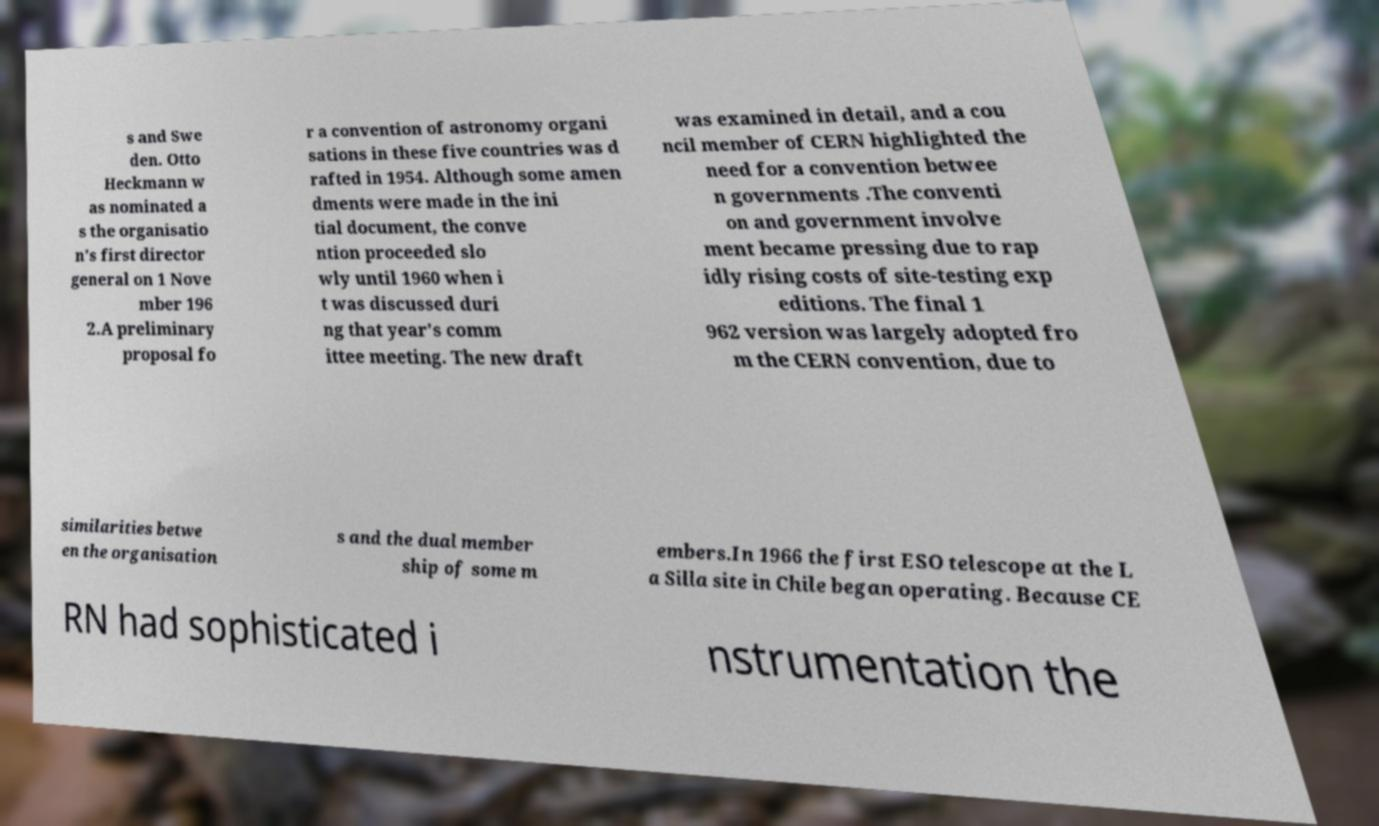What messages or text are displayed in this image? I need them in a readable, typed format. s and Swe den. Otto Heckmann w as nominated a s the organisatio n's first director general on 1 Nove mber 196 2.A preliminary proposal fo r a convention of astronomy organi sations in these five countries was d rafted in 1954. Although some amen dments were made in the ini tial document, the conve ntion proceeded slo wly until 1960 when i t was discussed duri ng that year's comm ittee meeting. The new draft was examined in detail, and a cou ncil member of CERN highlighted the need for a convention betwee n governments .The conventi on and government involve ment became pressing due to rap idly rising costs of site-testing exp editions. The final 1 962 version was largely adopted fro m the CERN convention, due to similarities betwe en the organisation s and the dual member ship of some m embers.In 1966 the first ESO telescope at the L a Silla site in Chile began operating. Because CE RN had sophisticated i nstrumentation the 